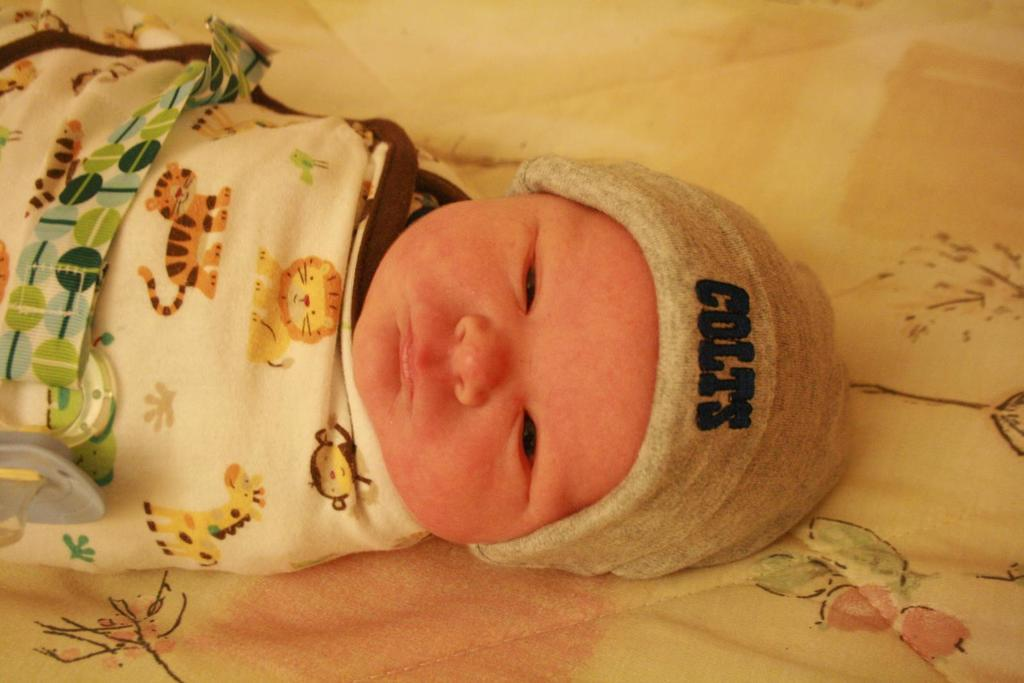What is the main subject of the image? The main subject of the image is a baby. Where is the baby located in the image? The baby is on a bed in the image. What is the baby wearing on their head? The baby is wearing a cap in the image. What type of road can be seen in the image? There is no road present in the image; it features a baby on a bed wearing a cap. 